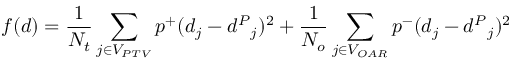Convert formula to latex. <formula><loc_0><loc_0><loc_500><loc_500>f ( d ) = \frac { 1 } { N _ { t } } \sum _ { j \in V _ { P T V } } p ^ { + } ( d _ { j } - { d ^ { P } } _ { j } ) ^ { 2 } + \frac { 1 } { N _ { o } } \sum _ { j \in V _ { O A R } } p ^ { - } ( d _ { j } - { d ^ { P } } _ { j } ) ^ { 2 }</formula> 